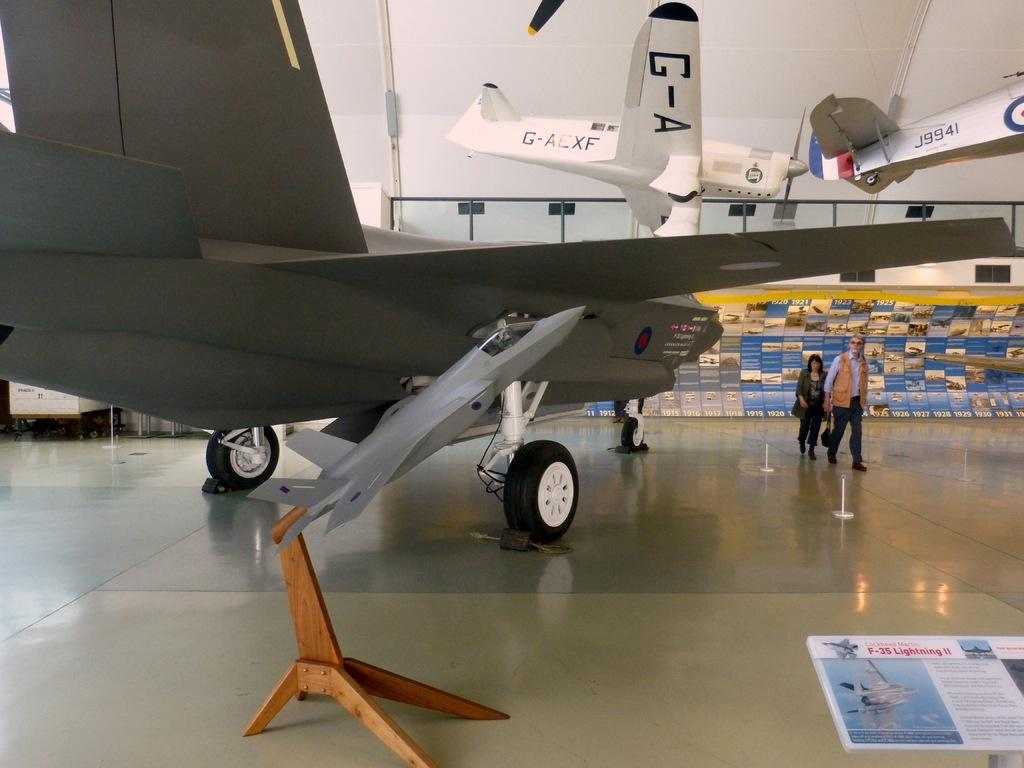<image>
Describe the image concisely. A man and a woman are walking through a museum that has an airplane with J9941 on it suspended from the ceiling. 